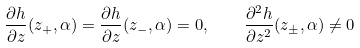<formula> <loc_0><loc_0><loc_500><loc_500>\frac { \partial h } { \partial z } ( z _ { + } , \alpha ) = \frac { \partial h } { \partial z } ( z _ { - } , \alpha ) = 0 , \quad \frac { \partial ^ { 2 } h } { \partial z ^ { 2 } } ( z _ { \pm } , \alpha ) \neq 0</formula> 